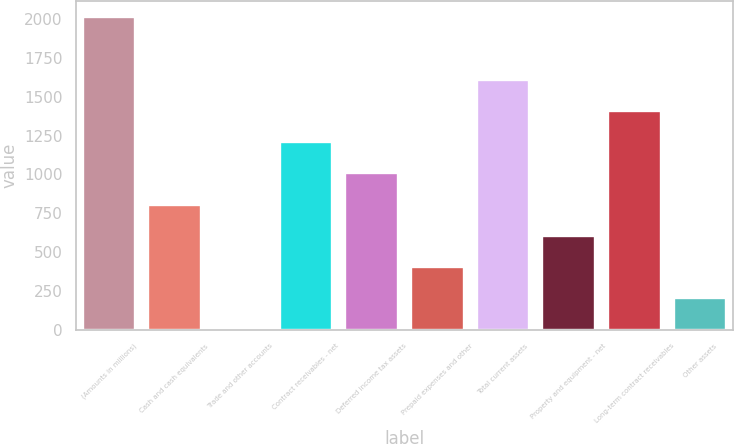Convert chart. <chart><loc_0><loc_0><loc_500><loc_500><bar_chart><fcel>(Amounts in millions)<fcel>Cash and cash equivalents<fcel>Trade and other accounts<fcel>Contract receivables - net<fcel>Deferred income tax assets<fcel>Prepaid expenses and other<fcel>Total current assets<fcel>Property and equipment - net<fcel>Long-term contract receivables<fcel>Other assets<nl><fcel>2013<fcel>805.5<fcel>0.5<fcel>1208<fcel>1006.75<fcel>403<fcel>1610.5<fcel>604.25<fcel>1409.25<fcel>201.75<nl></chart> 